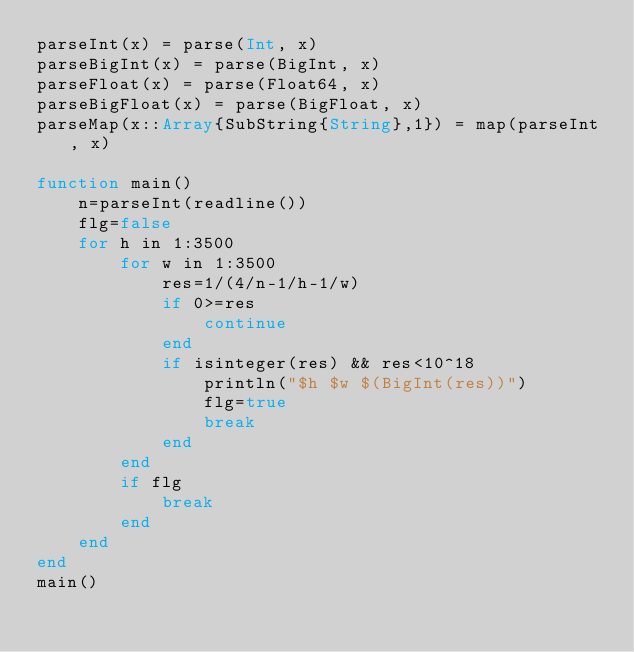<code> <loc_0><loc_0><loc_500><loc_500><_Julia_>parseInt(x) = parse(Int, x)
parseBigInt(x) = parse(BigInt, x)
parseFloat(x) = parse(Float64, x)
parseBigFloat(x) = parse(BigFloat, x)
parseMap(x::Array{SubString{String},1}) = map(parseInt, x)

function main()
    n=parseInt(readline())
    flg=false
    for h in 1:3500
        for w in 1:3500
            res=1/(4/n-1/h-1/w)
            if 0>=res
                continue
            end
            if isinteger(res) && res<10^18
                println("$h $w $(BigInt(res))")
                flg=true
                break
            end
        end
        if flg
            break
        end
    end
end
main()</code> 